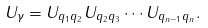Convert formula to latex. <formula><loc_0><loc_0><loc_500><loc_500>U _ { \gamma } = U _ { { q } _ { 1 } { q } _ { 2 } } U _ { { q } _ { 2 } { q } _ { 3 } } \cdots U _ { { q } _ { n - 1 } { q } _ { n } } .</formula> 